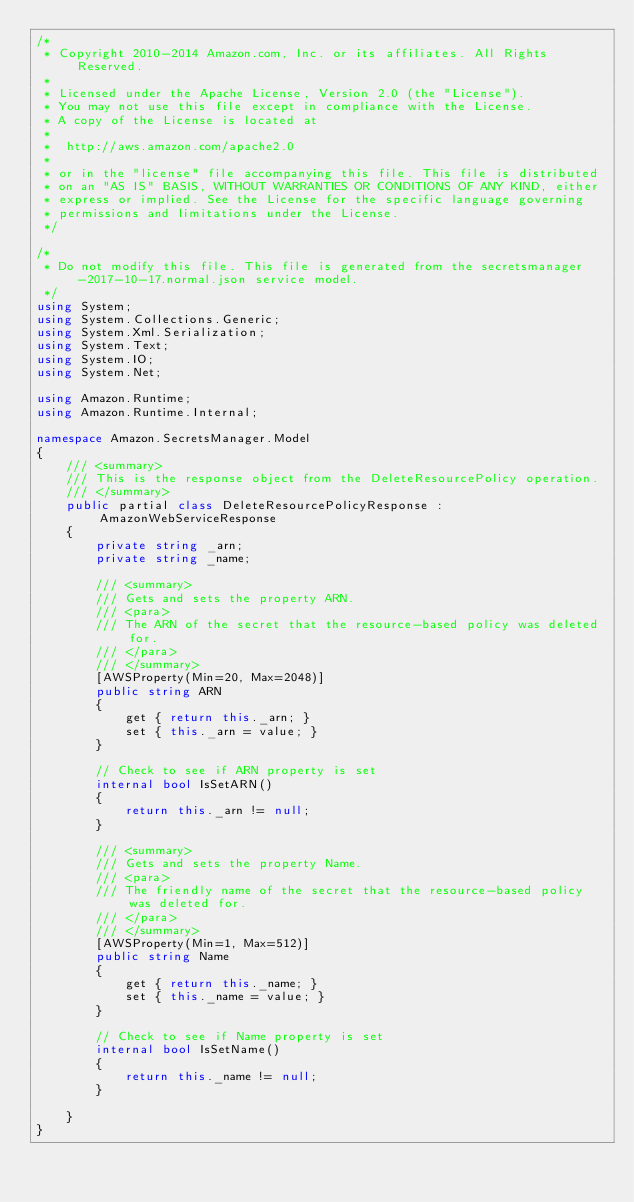Convert code to text. <code><loc_0><loc_0><loc_500><loc_500><_C#_>/*
 * Copyright 2010-2014 Amazon.com, Inc. or its affiliates. All Rights Reserved.
 * 
 * Licensed under the Apache License, Version 2.0 (the "License").
 * You may not use this file except in compliance with the License.
 * A copy of the License is located at
 * 
 *  http://aws.amazon.com/apache2.0
 * 
 * or in the "license" file accompanying this file. This file is distributed
 * on an "AS IS" BASIS, WITHOUT WARRANTIES OR CONDITIONS OF ANY KIND, either
 * express or implied. See the License for the specific language governing
 * permissions and limitations under the License.
 */

/*
 * Do not modify this file. This file is generated from the secretsmanager-2017-10-17.normal.json service model.
 */
using System;
using System.Collections.Generic;
using System.Xml.Serialization;
using System.Text;
using System.IO;
using System.Net;

using Amazon.Runtime;
using Amazon.Runtime.Internal;

namespace Amazon.SecretsManager.Model
{
    /// <summary>
    /// This is the response object from the DeleteResourcePolicy operation.
    /// </summary>
    public partial class DeleteResourcePolicyResponse : AmazonWebServiceResponse
    {
        private string _arn;
        private string _name;

        /// <summary>
        /// Gets and sets the property ARN. 
        /// <para>
        /// The ARN of the secret that the resource-based policy was deleted for.
        /// </para>
        /// </summary>
        [AWSProperty(Min=20, Max=2048)]
        public string ARN
        {
            get { return this._arn; }
            set { this._arn = value; }
        }

        // Check to see if ARN property is set
        internal bool IsSetARN()
        {
            return this._arn != null;
        }

        /// <summary>
        /// Gets and sets the property Name. 
        /// <para>
        /// The friendly name of the secret that the resource-based policy was deleted for.
        /// </para>
        /// </summary>
        [AWSProperty(Min=1, Max=512)]
        public string Name
        {
            get { return this._name; }
            set { this._name = value; }
        }

        // Check to see if Name property is set
        internal bool IsSetName()
        {
            return this._name != null;
        }

    }
}</code> 